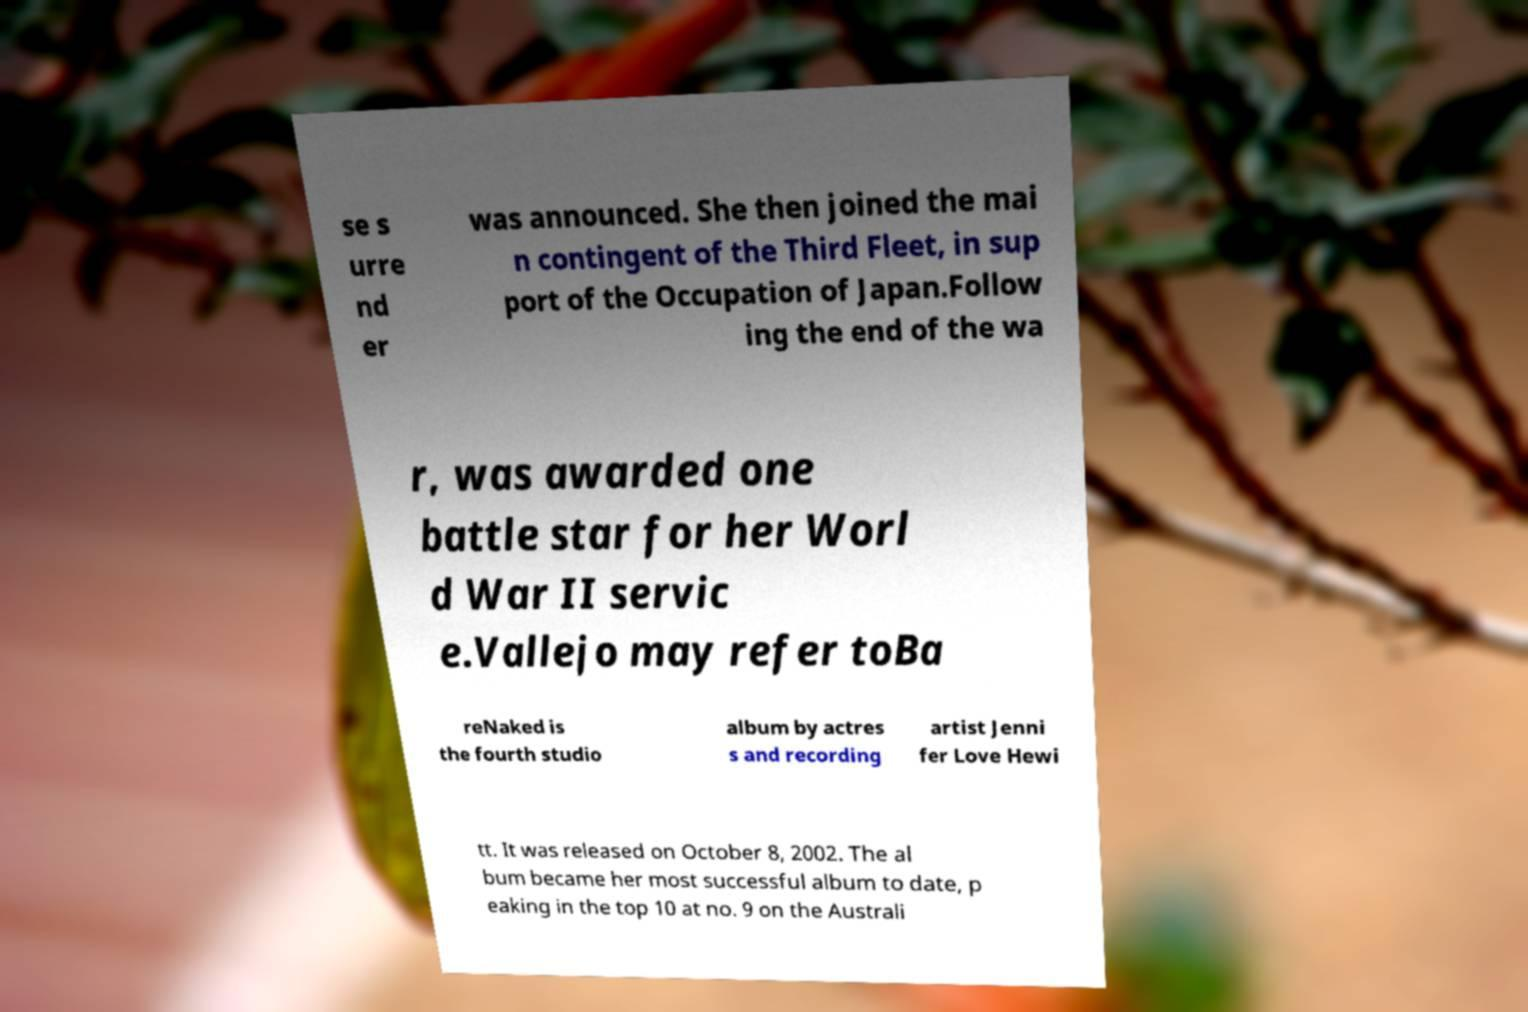There's text embedded in this image that I need extracted. Can you transcribe it verbatim? se s urre nd er was announced. She then joined the mai n contingent of the Third Fleet, in sup port of the Occupation of Japan.Follow ing the end of the wa r, was awarded one battle star for her Worl d War II servic e.Vallejo may refer toBa reNaked is the fourth studio album by actres s and recording artist Jenni fer Love Hewi tt. It was released on October 8, 2002. The al bum became her most successful album to date, p eaking in the top 10 at no. 9 on the Australi 